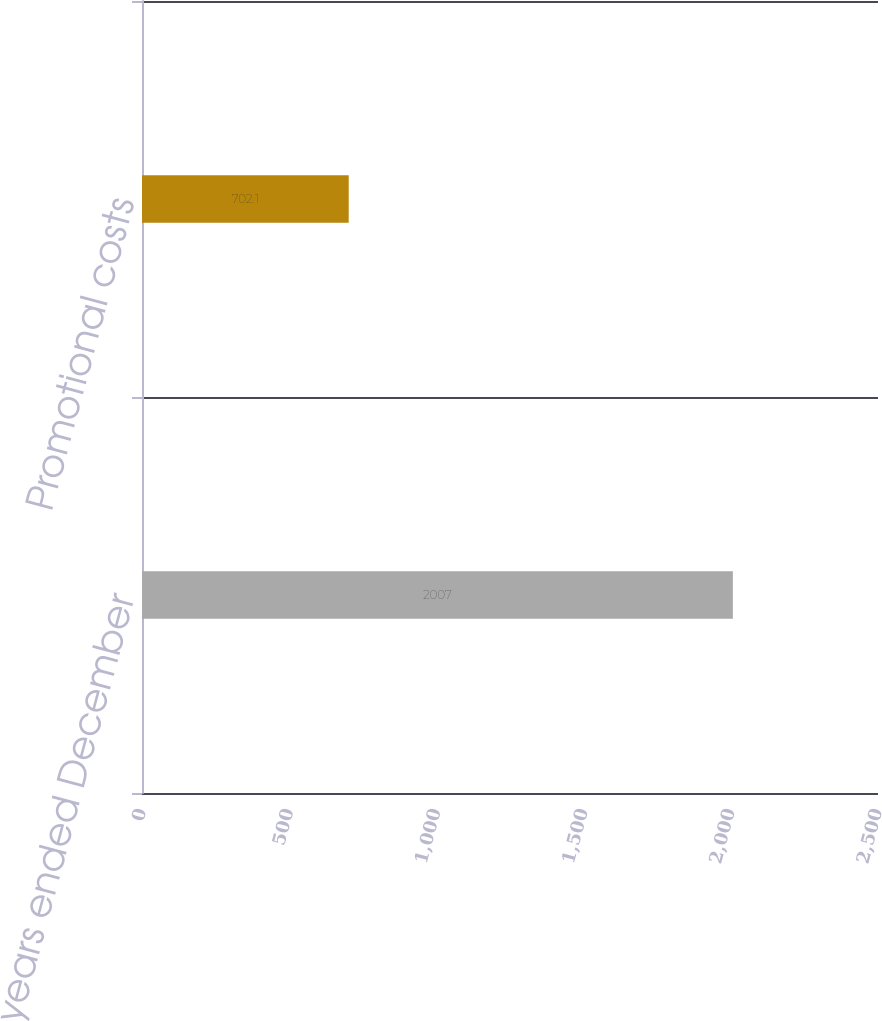Convert chart to OTSL. <chart><loc_0><loc_0><loc_500><loc_500><bar_chart><fcel>For the years ended December<fcel>Promotional costs<nl><fcel>2007<fcel>702.1<nl></chart> 